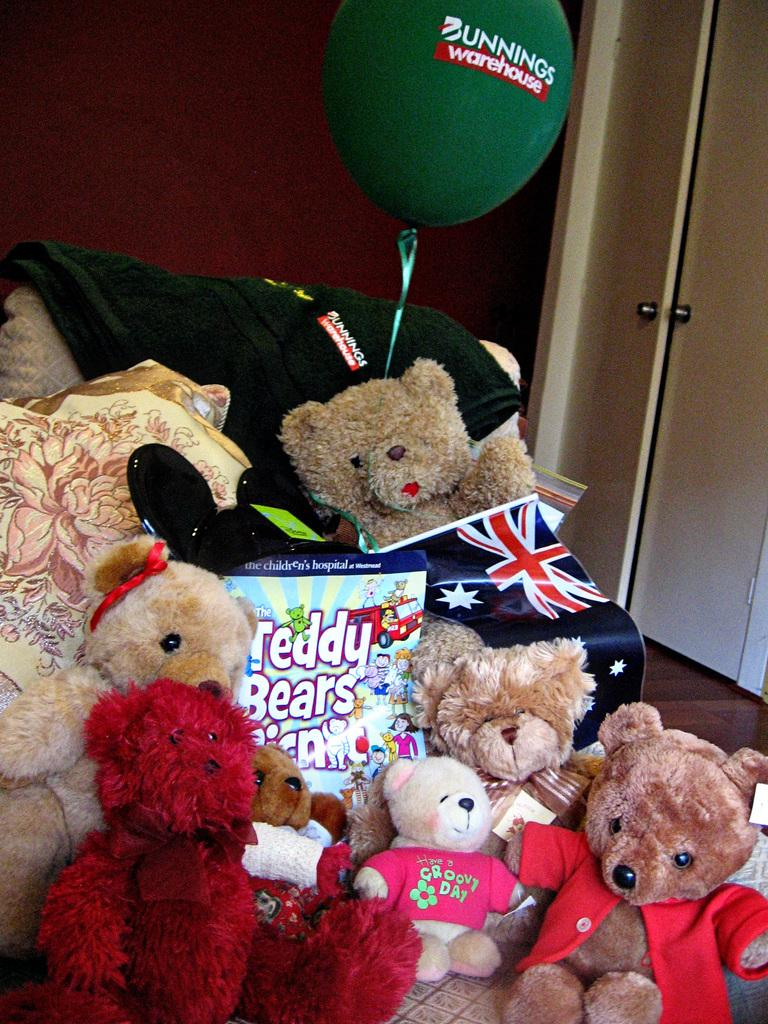What type of stuffed animals can be seen in the image? There are teddy bears in the image. What is hanging on the wall in the image? There is a poster and a flag in the image. What is placed on the sofa in the image? There are other objects on a sofa in the image. What is visible in the background of the image? There is a door and a door handle in the background of the image. What type of whip is being used to stir the oatmeal in the image? There is no whip or oatmeal present in the image. What type of pan is being used to cook the teddy bears in the image? There is no pan or cooking activity involving teddy bears in the image. 